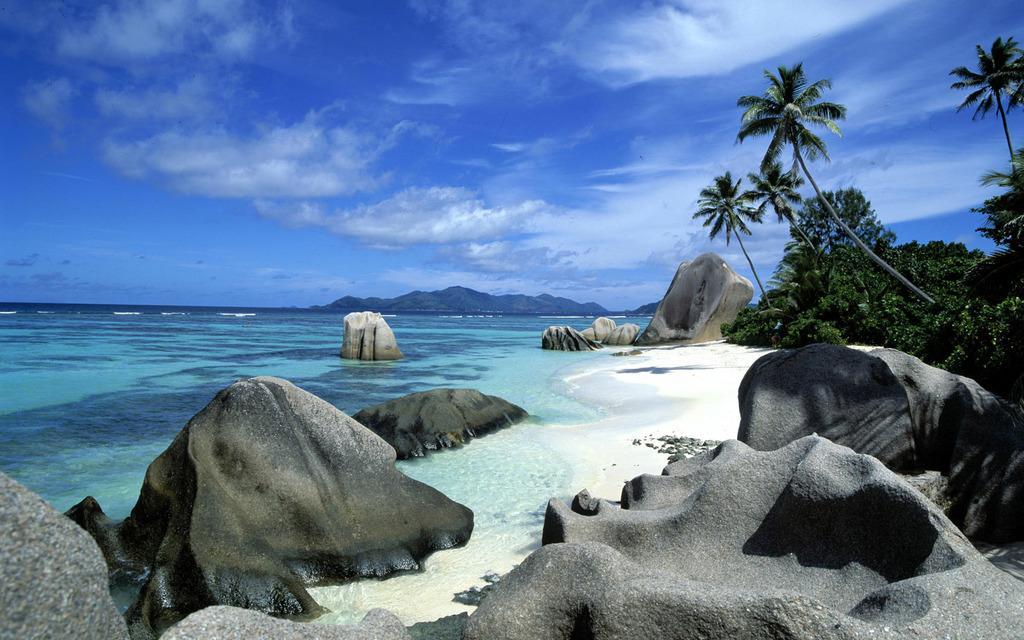Please provide a concise description of this image. In this image it seems like there is an ocean on the left side. On the right side there are stones on the shore. On the right side there are tall trees. At the top there is the sky. In the background there are hills. 